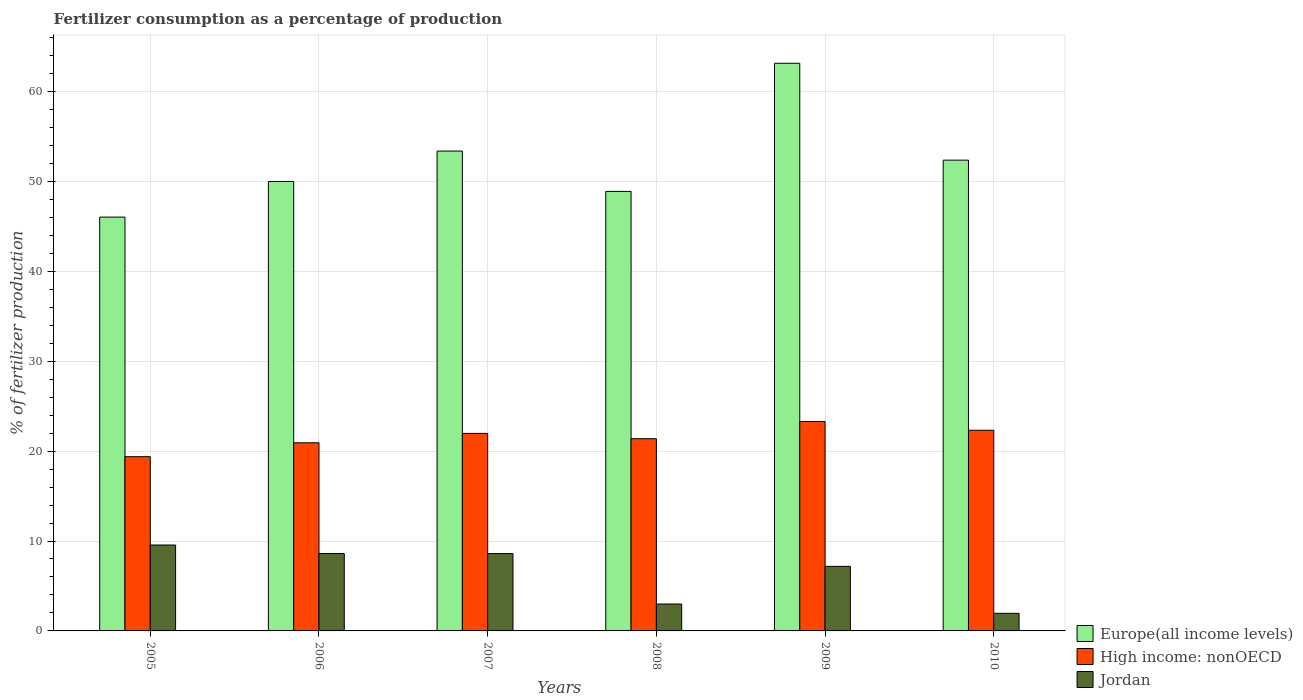How many different coloured bars are there?
Give a very brief answer. 3. What is the label of the 5th group of bars from the left?
Offer a very short reply. 2009. What is the percentage of fertilizers consumed in Europe(all income levels) in 2005?
Give a very brief answer. 46.02. Across all years, what is the maximum percentage of fertilizers consumed in Europe(all income levels)?
Keep it short and to the point. 63.13. Across all years, what is the minimum percentage of fertilizers consumed in High income: nonOECD?
Give a very brief answer. 19.38. In which year was the percentage of fertilizers consumed in Jordan minimum?
Make the answer very short. 2010. What is the total percentage of fertilizers consumed in Europe(all income levels) in the graph?
Ensure brevity in your answer.  313.75. What is the difference between the percentage of fertilizers consumed in High income: nonOECD in 2005 and that in 2006?
Offer a terse response. -1.55. What is the difference between the percentage of fertilizers consumed in Jordan in 2010 and the percentage of fertilizers consumed in High income: nonOECD in 2005?
Make the answer very short. -17.42. What is the average percentage of fertilizers consumed in Jordan per year?
Provide a succinct answer. 6.48. In the year 2008, what is the difference between the percentage of fertilizers consumed in High income: nonOECD and percentage of fertilizers consumed in Europe(all income levels)?
Offer a very short reply. -27.5. What is the ratio of the percentage of fertilizers consumed in Jordan in 2007 to that in 2009?
Give a very brief answer. 1.2. Is the difference between the percentage of fertilizers consumed in High income: nonOECD in 2005 and 2010 greater than the difference between the percentage of fertilizers consumed in Europe(all income levels) in 2005 and 2010?
Offer a very short reply. Yes. What is the difference between the highest and the second highest percentage of fertilizers consumed in Europe(all income levels)?
Your answer should be compact. 9.76. What is the difference between the highest and the lowest percentage of fertilizers consumed in Jordan?
Your response must be concise. 7.6. Is the sum of the percentage of fertilizers consumed in High income: nonOECD in 2007 and 2008 greater than the maximum percentage of fertilizers consumed in Jordan across all years?
Your answer should be compact. Yes. What does the 2nd bar from the left in 2006 represents?
Provide a succinct answer. High income: nonOECD. What does the 1st bar from the right in 2008 represents?
Provide a succinct answer. Jordan. Is it the case that in every year, the sum of the percentage of fertilizers consumed in High income: nonOECD and percentage of fertilizers consumed in Europe(all income levels) is greater than the percentage of fertilizers consumed in Jordan?
Give a very brief answer. Yes. How many years are there in the graph?
Your answer should be very brief. 6. What is the difference between two consecutive major ticks on the Y-axis?
Make the answer very short. 10. Does the graph contain any zero values?
Make the answer very short. No. What is the title of the graph?
Make the answer very short. Fertilizer consumption as a percentage of production. What is the label or title of the Y-axis?
Keep it short and to the point. % of fertilizer production. What is the % of fertilizer production in Europe(all income levels) in 2005?
Make the answer very short. 46.02. What is the % of fertilizer production of High income: nonOECD in 2005?
Offer a very short reply. 19.38. What is the % of fertilizer production of Jordan in 2005?
Make the answer very short. 9.56. What is the % of fertilizer production in Europe(all income levels) in 2006?
Your response must be concise. 49.98. What is the % of fertilizer production of High income: nonOECD in 2006?
Provide a short and direct response. 20.93. What is the % of fertilizer production of Jordan in 2006?
Offer a very short reply. 8.61. What is the % of fertilizer production of Europe(all income levels) in 2007?
Ensure brevity in your answer.  53.37. What is the % of fertilizer production of High income: nonOECD in 2007?
Make the answer very short. 21.97. What is the % of fertilizer production in Jordan in 2007?
Give a very brief answer. 8.6. What is the % of fertilizer production of Europe(all income levels) in 2008?
Your answer should be very brief. 48.88. What is the % of fertilizer production in High income: nonOECD in 2008?
Your response must be concise. 21.38. What is the % of fertilizer production in Jordan in 2008?
Your response must be concise. 2.99. What is the % of fertilizer production of Europe(all income levels) in 2009?
Offer a very short reply. 63.13. What is the % of fertilizer production in High income: nonOECD in 2009?
Provide a short and direct response. 23.29. What is the % of fertilizer production in Jordan in 2009?
Your answer should be compact. 7.18. What is the % of fertilizer production of Europe(all income levels) in 2010?
Your response must be concise. 52.36. What is the % of fertilizer production in High income: nonOECD in 2010?
Ensure brevity in your answer.  22.32. What is the % of fertilizer production of Jordan in 2010?
Provide a succinct answer. 1.96. Across all years, what is the maximum % of fertilizer production of Europe(all income levels)?
Your answer should be compact. 63.13. Across all years, what is the maximum % of fertilizer production of High income: nonOECD?
Your answer should be very brief. 23.29. Across all years, what is the maximum % of fertilizer production in Jordan?
Provide a short and direct response. 9.56. Across all years, what is the minimum % of fertilizer production of Europe(all income levels)?
Offer a very short reply. 46.02. Across all years, what is the minimum % of fertilizer production in High income: nonOECD?
Make the answer very short. 19.38. Across all years, what is the minimum % of fertilizer production in Jordan?
Give a very brief answer. 1.96. What is the total % of fertilizer production of Europe(all income levels) in the graph?
Keep it short and to the point. 313.75. What is the total % of fertilizer production in High income: nonOECD in the graph?
Your answer should be very brief. 129.26. What is the total % of fertilizer production of Jordan in the graph?
Give a very brief answer. 38.9. What is the difference between the % of fertilizer production of Europe(all income levels) in 2005 and that in 2006?
Offer a terse response. -3.96. What is the difference between the % of fertilizer production of High income: nonOECD in 2005 and that in 2006?
Ensure brevity in your answer.  -1.55. What is the difference between the % of fertilizer production in Jordan in 2005 and that in 2006?
Offer a terse response. 0.94. What is the difference between the % of fertilizer production of Europe(all income levels) in 2005 and that in 2007?
Offer a terse response. -7.35. What is the difference between the % of fertilizer production of High income: nonOECD in 2005 and that in 2007?
Give a very brief answer. -2.59. What is the difference between the % of fertilizer production in Jordan in 2005 and that in 2007?
Provide a succinct answer. 0.95. What is the difference between the % of fertilizer production in Europe(all income levels) in 2005 and that in 2008?
Provide a succinct answer. -2.86. What is the difference between the % of fertilizer production of High income: nonOECD in 2005 and that in 2008?
Your response must be concise. -2. What is the difference between the % of fertilizer production of Jordan in 2005 and that in 2008?
Offer a very short reply. 6.56. What is the difference between the % of fertilizer production of Europe(all income levels) in 2005 and that in 2009?
Offer a very short reply. -17.11. What is the difference between the % of fertilizer production of High income: nonOECD in 2005 and that in 2009?
Offer a very short reply. -3.91. What is the difference between the % of fertilizer production in Jordan in 2005 and that in 2009?
Provide a short and direct response. 2.38. What is the difference between the % of fertilizer production of Europe(all income levels) in 2005 and that in 2010?
Make the answer very short. -6.34. What is the difference between the % of fertilizer production of High income: nonOECD in 2005 and that in 2010?
Provide a succinct answer. -2.94. What is the difference between the % of fertilizer production in Jordan in 2005 and that in 2010?
Keep it short and to the point. 7.6. What is the difference between the % of fertilizer production in Europe(all income levels) in 2006 and that in 2007?
Your answer should be very brief. -3.39. What is the difference between the % of fertilizer production of High income: nonOECD in 2006 and that in 2007?
Ensure brevity in your answer.  -1.04. What is the difference between the % of fertilizer production in Jordan in 2006 and that in 2007?
Your response must be concise. 0.01. What is the difference between the % of fertilizer production in Europe(all income levels) in 2006 and that in 2008?
Offer a very short reply. 1.1. What is the difference between the % of fertilizer production in High income: nonOECD in 2006 and that in 2008?
Ensure brevity in your answer.  -0.45. What is the difference between the % of fertilizer production in Jordan in 2006 and that in 2008?
Provide a succinct answer. 5.62. What is the difference between the % of fertilizer production of Europe(all income levels) in 2006 and that in 2009?
Provide a short and direct response. -13.15. What is the difference between the % of fertilizer production in High income: nonOECD in 2006 and that in 2009?
Your answer should be compact. -2.37. What is the difference between the % of fertilizer production in Jordan in 2006 and that in 2009?
Your response must be concise. 1.43. What is the difference between the % of fertilizer production of Europe(all income levels) in 2006 and that in 2010?
Your response must be concise. -2.38. What is the difference between the % of fertilizer production of High income: nonOECD in 2006 and that in 2010?
Ensure brevity in your answer.  -1.39. What is the difference between the % of fertilizer production of Jordan in 2006 and that in 2010?
Make the answer very short. 6.66. What is the difference between the % of fertilizer production of Europe(all income levels) in 2007 and that in 2008?
Offer a terse response. 4.49. What is the difference between the % of fertilizer production of High income: nonOECD in 2007 and that in 2008?
Your answer should be very brief. 0.59. What is the difference between the % of fertilizer production of Jordan in 2007 and that in 2008?
Offer a terse response. 5.61. What is the difference between the % of fertilizer production in Europe(all income levels) in 2007 and that in 2009?
Provide a short and direct response. -9.76. What is the difference between the % of fertilizer production in High income: nonOECD in 2007 and that in 2009?
Offer a terse response. -1.33. What is the difference between the % of fertilizer production of Jordan in 2007 and that in 2009?
Keep it short and to the point. 1.42. What is the difference between the % of fertilizer production in Europe(all income levels) in 2007 and that in 2010?
Give a very brief answer. 1.01. What is the difference between the % of fertilizer production in High income: nonOECD in 2007 and that in 2010?
Give a very brief answer. -0.35. What is the difference between the % of fertilizer production of Jordan in 2007 and that in 2010?
Your answer should be very brief. 6.65. What is the difference between the % of fertilizer production in Europe(all income levels) in 2008 and that in 2009?
Offer a very short reply. -14.25. What is the difference between the % of fertilizer production in High income: nonOECD in 2008 and that in 2009?
Your answer should be very brief. -1.91. What is the difference between the % of fertilizer production of Jordan in 2008 and that in 2009?
Offer a very short reply. -4.19. What is the difference between the % of fertilizer production of Europe(all income levels) in 2008 and that in 2010?
Your answer should be very brief. -3.48. What is the difference between the % of fertilizer production of High income: nonOECD in 2008 and that in 2010?
Your response must be concise. -0.94. What is the difference between the % of fertilizer production of Jordan in 2008 and that in 2010?
Keep it short and to the point. 1.04. What is the difference between the % of fertilizer production in Europe(all income levels) in 2009 and that in 2010?
Make the answer very short. 10.77. What is the difference between the % of fertilizer production of Jordan in 2009 and that in 2010?
Your answer should be very brief. 5.22. What is the difference between the % of fertilizer production in Europe(all income levels) in 2005 and the % of fertilizer production in High income: nonOECD in 2006?
Give a very brief answer. 25.1. What is the difference between the % of fertilizer production in Europe(all income levels) in 2005 and the % of fertilizer production in Jordan in 2006?
Your answer should be very brief. 37.41. What is the difference between the % of fertilizer production in High income: nonOECD in 2005 and the % of fertilizer production in Jordan in 2006?
Offer a terse response. 10.76. What is the difference between the % of fertilizer production of Europe(all income levels) in 2005 and the % of fertilizer production of High income: nonOECD in 2007?
Your response must be concise. 24.06. What is the difference between the % of fertilizer production of Europe(all income levels) in 2005 and the % of fertilizer production of Jordan in 2007?
Offer a very short reply. 37.42. What is the difference between the % of fertilizer production of High income: nonOECD in 2005 and the % of fertilizer production of Jordan in 2007?
Provide a short and direct response. 10.78. What is the difference between the % of fertilizer production in Europe(all income levels) in 2005 and the % of fertilizer production in High income: nonOECD in 2008?
Provide a succinct answer. 24.64. What is the difference between the % of fertilizer production in Europe(all income levels) in 2005 and the % of fertilizer production in Jordan in 2008?
Keep it short and to the point. 43.03. What is the difference between the % of fertilizer production in High income: nonOECD in 2005 and the % of fertilizer production in Jordan in 2008?
Ensure brevity in your answer.  16.39. What is the difference between the % of fertilizer production in Europe(all income levels) in 2005 and the % of fertilizer production in High income: nonOECD in 2009?
Offer a very short reply. 22.73. What is the difference between the % of fertilizer production of Europe(all income levels) in 2005 and the % of fertilizer production of Jordan in 2009?
Provide a short and direct response. 38.84. What is the difference between the % of fertilizer production of High income: nonOECD in 2005 and the % of fertilizer production of Jordan in 2009?
Give a very brief answer. 12.2. What is the difference between the % of fertilizer production in Europe(all income levels) in 2005 and the % of fertilizer production in High income: nonOECD in 2010?
Offer a terse response. 23.71. What is the difference between the % of fertilizer production of Europe(all income levels) in 2005 and the % of fertilizer production of Jordan in 2010?
Make the answer very short. 44.07. What is the difference between the % of fertilizer production in High income: nonOECD in 2005 and the % of fertilizer production in Jordan in 2010?
Provide a short and direct response. 17.42. What is the difference between the % of fertilizer production of Europe(all income levels) in 2006 and the % of fertilizer production of High income: nonOECD in 2007?
Your answer should be very brief. 28.02. What is the difference between the % of fertilizer production of Europe(all income levels) in 2006 and the % of fertilizer production of Jordan in 2007?
Offer a very short reply. 41.38. What is the difference between the % of fertilizer production in High income: nonOECD in 2006 and the % of fertilizer production in Jordan in 2007?
Make the answer very short. 12.32. What is the difference between the % of fertilizer production in Europe(all income levels) in 2006 and the % of fertilizer production in High income: nonOECD in 2008?
Keep it short and to the point. 28.6. What is the difference between the % of fertilizer production of Europe(all income levels) in 2006 and the % of fertilizer production of Jordan in 2008?
Provide a succinct answer. 46.99. What is the difference between the % of fertilizer production in High income: nonOECD in 2006 and the % of fertilizer production in Jordan in 2008?
Make the answer very short. 17.93. What is the difference between the % of fertilizer production in Europe(all income levels) in 2006 and the % of fertilizer production in High income: nonOECD in 2009?
Keep it short and to the point. 26.69. What is the difference between the % of fertilizer production of Europe(all income levels) in 2006 and the % of fertilizer production of Jordan in 2009?
Provide a short and direct response. 42.8. What is the difference between the % of fertilizer production in High income: nonOECD in 2006 and the % of fertilizer production in Jordan in 2009?
Offer a very short reply. 13.75. What is the difference between the % of fertilizer production of Europe(all income levels) in 2006 and the % of fertilizer production of High income: nonOECD in 2010?
Keep it short and to the point. 27.67. What is the difference between the % of fertilizer production in Europe(all income levels) in 2006 and the % of fertilizer production in Jordan in 2010?
Ensure brevity in your answer.  48.03. What is the difference between the % of fertilizer production of High income: nonOECD in 2006 and the % of fertilizer production of Jordan in 2010?
Give a very brief answer. 18.97. What is the difference between the % of fertilizer production in Europe(all income levels) in 2007 and the % of fertilizer production in High income: nonOECD in 2008?
Provide a short and direct response. 31.99. What is the difference between the % of fertilizer production of Europe(all income levels) in 2007 and the % of fertilizer production of Jordan in 2008?
Keep it short and to the point. 50.38. What is the difference between the % of fertilizer production of High income: nonOECD in 2007 and the % of fertilizer production of Jordan in 2008?
Provide a succinct answer. 18.97. What is the difference between the % of fertilizer production in Europe(all income levels) in 2007 and the % of fertilizer production in High income: nonOECD in 2009?
Your answer should be compact. 30.08. What is the difference between the % of fertilizer production of Europe(all income levels) in 2007 and the % of fertilizer production of Jordan in 2009?
Keep it short and to the point. 46.19. What is the difference between the % of fertilizer production in High income: nonOECD in 2007 and the % of fertilizer production in Jordan in 2009?
Provide a succinct answer. 14.79. What is the difference between the % of fertilizer production in Europe(all income levels) in 2007 and the % of fertilizer production in High income: nonOECD in 2010?
Offer a terse response. 31.05. What is the difference between the % of fertilizer production in Europe(all income levels) in 2007 and the % of fertilizer production in Jordan in 2010?
Ensure brevity in your answer.  51.41. What is the difference between the % of fertilizer production of High income: nonOECD in 2007 and the % of fertilizer production of Jordan in 2010?
Your answer should be very brief. 20.01. What is the difference between the % of fertilizer production of Europe(all income levels) in 2008 and the % of fertilizer production of High income: nonOECD in 2009?
Give a very brief answer. 25.59. What is the difference between the % of fertilizer production in Europe(all income levels) in 2008 and the % of fertilizer production in Jordan in 2009?
Make the answer very short. 41.7. What is the difference between the % of fertilizer production in High income: nonOECD in 2008 and the % of fertilizer production in Jordan in 2009?
Offer a terse response. 14.2. What is the difference between the % of fertilizer production in Europe(all income levels) in 2008 and the % of fertilizer production in High income: nonOECD in 2010?
Offer a terse response. 26.57. What is the difference between the % of fertilizer production of Europe(all income levels) in 2008 and the % of fertilizer production of Jordan in 2010?
Your answer should be very brief. 46.93. What is the difference between the % of fertilizer production of High income: nonOECD in 2008 and the % of fertilizer production of Jordan in 2010?
Offer a terse response. 19.42. What is the difference between the % of fertilizer production of Europe(all income levels) in 2009 and the % of fertilizer production of High income: nonOECD in 2010?
Your answer should be compact. 40.82. What is the difference between the % of fertilizer production of Europe(all income levels) in 2009 and the % of fertilizer production of Jordan in 2010?
Provide a succinct answer. 61.18. What is the difference between the % of fertilizer production in High income: nonOECD in 2009 and the % of fertilizer production in Jordan in 2010?
Offer a terse response. 21.34. What is the average % of fertilizer production of Europe(all income levels) per year?
Your answer should be very brief. 52.29. What is the average % of fertilizer production in High income: nonOECD per year?
Keep it short and to the point. 21.54. What is the average % of fertilizer production of Jordan per year?
Your answer should be very brief. 6.48. In the year 2005, what is the difference between the % of fertilizer production of Europe(all income levels) and % of fertilizer production of High income: nonOECD?
Your answer should be compact. 26.64. In the year 2005, what is the difference between the % of fertilizer production of Europe(all income levels) and % of fertilizer production of Jordan?
Your answer should be very brief. 36.47. In the year 2005, what is the difference between the % of fertilizer production in High income: nonOECD and % of fertilizer production in Jordan?
Your response must be concise. 9.82. In the year 2006, what is the difference between the % of fertilizer production in Europe(all income levels) and % of fertilizer production in High income: nonOECD?
Provide a short and direct response. 29.06. In the year 2006, what is the difference between the % of fertilizer production in Europe(all income levels) and % of fertilizer production in Jordan?
Provide a succinct answer. 41.37. In the year 2006, what is the difference between the % of fertilizer production of High income: nonOECD and % of fertilizer production of Jordan?
Keep it short and to the point. 12.31. In the year 2007, what is the difference between the % of fertilizer production of Europe(all income levels) and % of fertilizer production of High income: nonOECD?
Provide a succinct answer. 31.4. In the year 2007, what is the difference between the % of fertilizer production of Europe(all income levels) and % of fertilizer production of Jordan?
Make the answer very short. 44.77. In the year 2007, what is the difference between the % of fertilizer production of High income: nonOECD and % of fertilizer production of Jordan?
Ensure brevity in your answer.  13.36. In the year 2008, what is the difference between the % of fertilizer production in Europe(all income levels) and % of fertilizer production in High income: nonOECD?
Make the answer very short. 27.5. In the year 2008, what is the difference between the % of fertilizer production of Europe(all income levels) and % of fertilizer production of Jordan?
Your answer should be very brief. 45.89. In the year 2008, what is the difference between the % of fertilizer production in High income: nonOECD and % of fertilizer production in Jordan?
Your response must be concise. 18.39. In the year 2009, what is the difference between the % of fertilizer production of Europe(all income levels) and % of fertilizer production of High income: nonOECD?
Provide a short and direct response. 39.84. In the year 2009, what is the difference between the % of fertilizer production of Europe(all income levels) and % of fertilizer production of Jordan?
Give a very brief answer. 55.96. In the year 2009, what is the difference between the % of fertilizer production of High income: nonOECD and % of fertilizer production of Jordan?
Provide a short and direct response. 16.11. In the year 2010, what is the difference between the % of fertilizer production of Europe(all income levels) and % of fertilizer production of High income: nonOECD?
Give a very brief answer. 30.04. In the year 2010, what is the difference between the % of fertilizer production of Europe(all income levels) and % of fertilizer production of Jordan?
Your answer should be very brief. 50.4. In the year 2010, what is the difference between the % of fertilizer production in High income: nonOECD and % of fertilizer production in Jordan?
Your answer should be very brief. 20.36. What is the ratio of the % of fertilizer production in Europe(all income levels) in 2005 to that in 2006?
Your answer should be compact. 0.92. What is the ratio of the % of fertilizer production of High income: nonOECD in 2005 to that in 2006?
Give a very brief answer. 0.93. What is the ratio of the % of fertilizer production of Jordan in 2005 to that in 2006?
Provide a succinct answer. 1.11. What is the ratio of the % of fertilizer production of Europe(all income levels) in 2005 to that in 2007?
Provide a succinct answer. 0.86. What is the ratio of the % of fertilizer production in High income: nonOECD in 2005 to that in 2007?
Provide a short and direct response. 0.88. What is the ratio of the % of fertilizer production of Jordan in 2005 to that in 2007?
Your response must be concise. 1.11. What is the ratio of the % of fertilizer production in Europe(all income levels) in 2005 to that in 2008?
Make the answer very short. 0.94. What is the ratio of the % of fertilizer production in High income: nonOECD in 2005 to that in 2008?
Your answer should be compact. 0.91. What is the ratio of the % of fertilizer production in Jordan in 2005 to that in 2008?
Ensure brevity in your answer.  3.19. What is the ratio of the % of fertilizer production in Europe(all income levels) in 2005 to that in 2009?
Offer a terse response. 0.73. What is the ratio of the % of fertilizer production of High income: nonOECD in 2005 to that in 2009?
Your answer should be compact. 0.83. What is the ratio of the % of fertilizer production in Jordan in 2005 to that in 2009?
Offer a terse response. 1.33. What is the ratio of the % of fertilizer production of Europe(all income levels) in 2005 to that in 2010?
Provide a short and direct response. 0.88. What is the ratio of the % of fertilizer production in High income: nonOECD in 2005 to that in 2010?
Ensure brevity in your answer.  0.87. What is the ratio of the % of fertilizer production of Jordan in 2005 to that in 2010?
Offer a terse response. 4.88. What is the ratio of the % of fertilizer production of Europe(all income levels) in 2006 to that in 2007?
Keep it short and to the point. 0.94. What is the ratio of the % of fertilizer production of High income: nonOECD in 2006 to that in 2007?
Offer a very short reply. 0.95. What is the ratio of the % of fertilizer production in Jordan in 2006 to that in 2007?
Provide a succinct answer. 1. What is the ratio of the % of fertilizer production of Europe(all income levels) in 2006 to that in 2008?
Ensure brevity in your answer.  1.02. What is the ratio of the % of fertilizer production in High income: nonOECD in 2006 to that in 2008?
Provide a short and direct response. 0.98. What is the ratio of the % of fertilizer production in Jordan in 2006 to that in 2008?
Ensure brevity in your answer.  2.88. What is the ratio of the % of fertilizer production of Europe(all income levels) in 2006 to that in 2009?
Offer a terse response. 0.79. What is the ratio of the % of fertilizer production in High income: nonOECD in 2006 to that in 2009?
Offer a terse response. 0.9. What is the ratio of the % of fertilizer production in Jordan in 2006 to that in 2009?
Provide a succinct answer. 1.2. What is the ratio of the % of fertilizer production in Europe(all income levels) in 2006 to that in 2010?
Ensure brevity in your answer.  0.95. What is the ratio of the % of fertilizer production of High income: nonOECD in 2006 to that in 2010?
Keep it short and to the point. 0.94. What is the ratio of the % of fertilizer production of Jordan in 2006 to that in 2010?
Offer a terse response. 4.4. What is the ratio of the % of fertilizer production in Europe(all income levels) in 2007 to that in 2008?
Your answer should be very brief. 1.09. What is the ratio of the % of fertilizer production of High income: nonOECD in 2007 to that in 2008?
Your answer should be compact. 1.03. What is the ratio of the % of fertilizer production of Jordan in 2007 to that in 2008?
Keep it short and to the point. 2.87. What is the ratio of the % of fertilizer production of Europe(all income levels) in 2007 to that in 2009?
Your answer should be very brief. 0.85. What is the ratio of the % of fertilizer production in High income: nonOECD in 2007 to that in 2009?
Your answer should be compact. 0.94. What is the ratio of the % of fertilizer production of Jordan in 2007 to that in 2009?
Provide a short and direct response. 1.2. What is the ratio of the % of fertilizer production in Europe(all income levels) in 2007 to that in 2010?
Offer a very short reply. 1.02. What is the ratio of the % of fertilizer production in High income: nonOECD in 2007 to that in 2010?
Offer a very short reply. 0.98. What is the ratio of the % of fertilizer production of Jordan in 2007 to that in 2010?
Give a very brief answer. 4.39. What is the ratio of the % of fertilizer production in Europe(all income levels) in 2008 to that in 2009?
Provide a short and direct response. 0.77. What is the ratio of the % of fertilizer production of High income: nonOECD in 2008 to that in 2009?
Provide a succinct answer. 0.92. What is the ratio of the % of fertilizer production of Jordan in 2008 to that in 2009?
Give a very brief answer. 0.42. What is the ratio of the % of fertilizer production of Europe(all income levels) in 2008 to that in 2010?
Your answer should be very brief. 0.93. What is the ratio of the % of fertilizer production of High income: nonOECD in 2008 to that in 2010?
Make the answer very short. 0.96. What is the ratio of the % of fertilizer production in Jordan in 2008 to that in 2010?
Keep it short and to the point. 1.53. What is the ratio of the % of fertilizer production of Europe(all income levels) in 2009 to that in 2010?
Ensure brevity in your answer.  1.21. What is the ratio of the % of fertilizer production in High income: nonOECD in 2009 to that in 2010?
Offer a terse response. 1.04. What is the ratio of the % of fertilizer production of Jordan in 2009 to that in 2010?
Your answer should be compact. 3.67. What is the difference between the highest and the second highest % of fertilizer production of Europe(all income levels)?
Your answer should be compact. 9.76. What is the difference between the highest and the second highest % of fertilizer production in High income: nonOECD?
Your response must be concise. 0.97. What is the difference between the highest and the second highest % of fertilizer production in Jordan?
Make the answer very short. 0.94. What is the difference between the highest and the lowest % of fertilizer production of Europe(all income levels)?
Provide a short and direct response. 17.11. What is the difference between the highest and the lowest % of fertilizer production of High income: nonOECD?
Your answer should be compact. 3.91. What is the difference between the highest and the lowest % of fertilizer production in Jordan?
Provide a succinct answer. 7.6. 